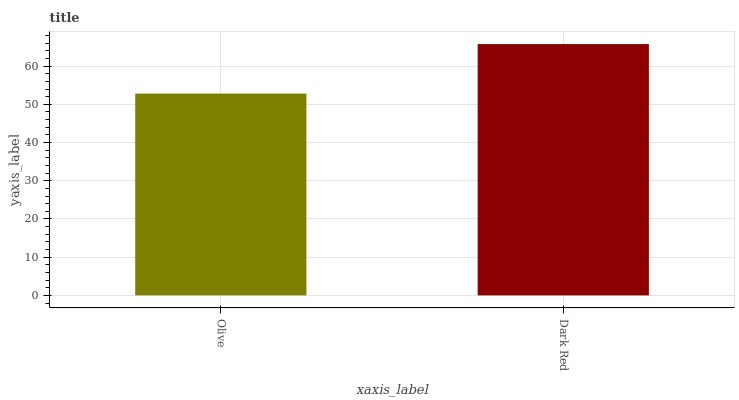Is Dark Red the minimum?
Answer yes or no. No. Is Dark Red greater than Olive?
Answer yes or no. Yes. Is Olive less than Dark Red?
Answer yes or no. Yes. Is Olive greater than Dark Red?
Answer yes or no. No. Is Dark Red less than Olive?
Answer yes or no. No. Is Dark Red the high median?
Answer yes or no. Yes. Is Olive the low median?
Answer yes or no. Yes. Is Olive the high median?
Answer yes or no. No. Is Dark Red the low median?
Answer yes or no. No. 